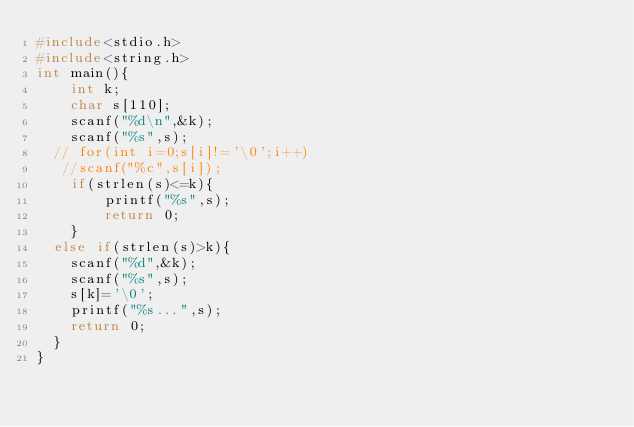<code> <loc_0><loc_0><loc_500><loc_500><_C_>#include<stdio.h>
#include<string.h>
int main(){
    int k;
    char s[110];
    scanf("%d\n",&k);
    scanf("%s",s);
  // for(int i=0;s[i]!='\0';i++)
   //scanf("%c",s[i]);
    if(strlen(s)<=k){
        printf("%s",s);
        return 0;
    }
  else if(strlen(s)>k){
    scanf("%d",&k);
    scanf("%s",s);
    s[k]='\0';
    printf("%s...",s);
    return 0;
  }
}
</code> 